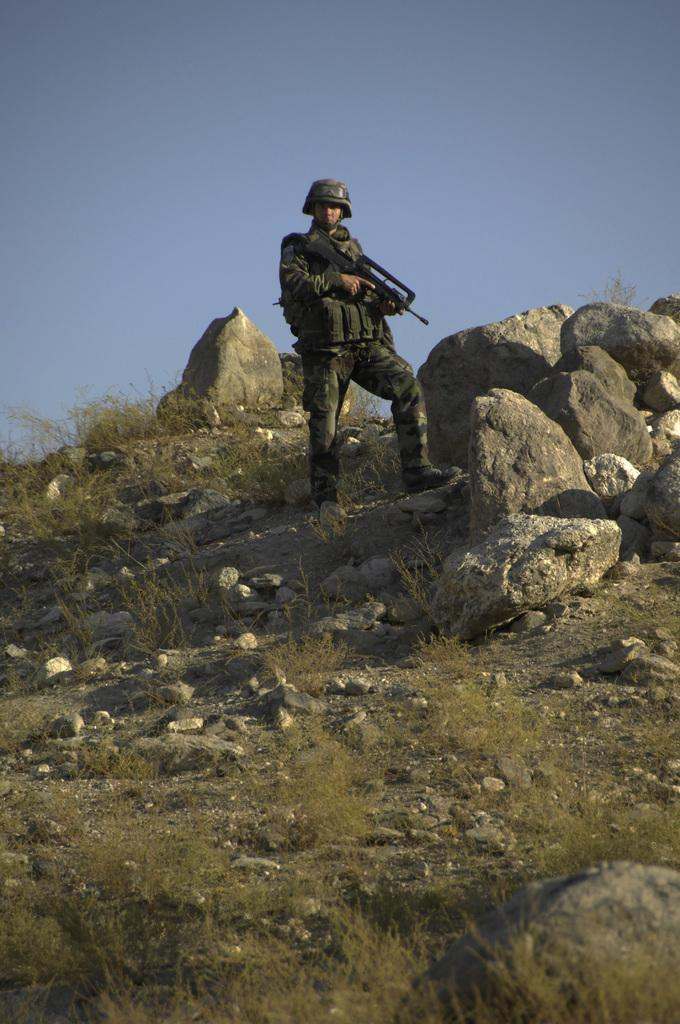Who is in the image? There is a man in the image. What is the man holding? The man is holding a gun. What type of terrain is visible in the image? There is grass visible in the image, along with stones and rocks. What can be seen in the background of the image? The sky is visible in the background of the image. What type of clam is visible in the image? There are no clams present in the image. Can you see a monkey holding a club in the image? There is no monkey or club present in the image. 